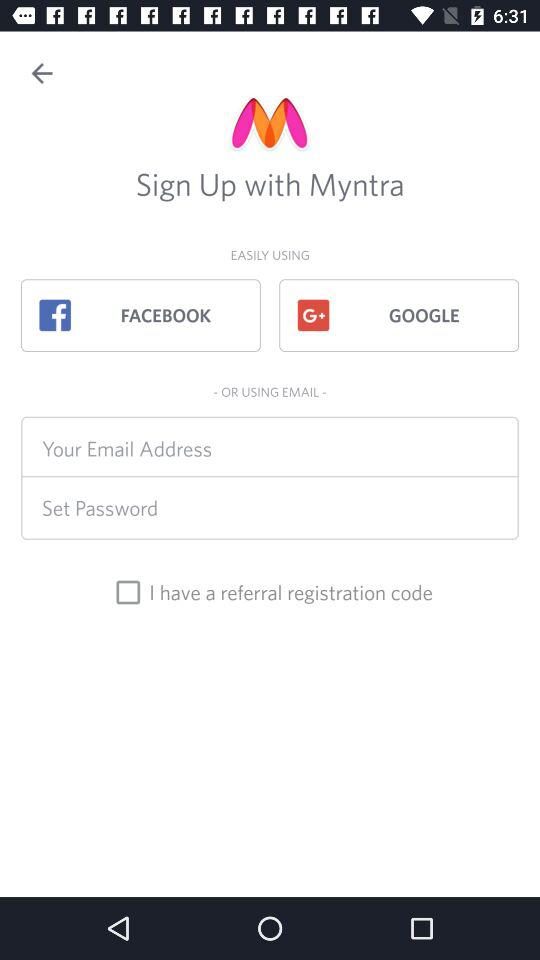What is the app name? The app name is "Myntra". 